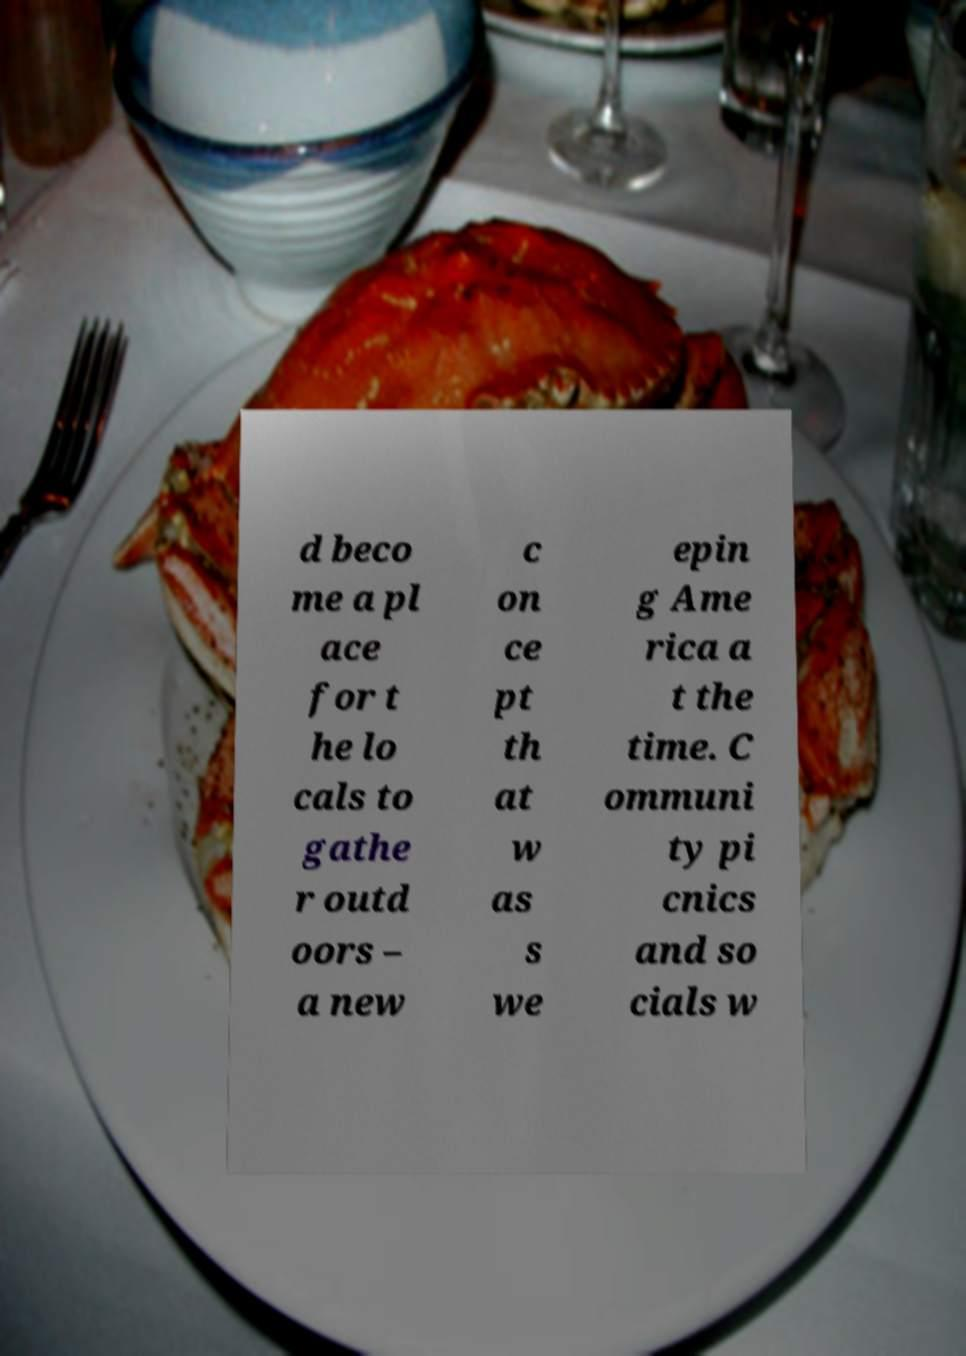Could you extract and type out the text from this image? d beco me a pl ace for t he lo cals to gathe r outd oors – a new c on ce pt th at w as s we epin g Ame rica a t the time. C ommuni ty pi cnics and so cials w 